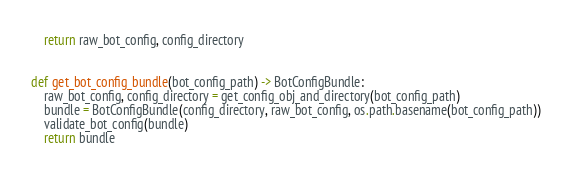<code> <loc_0><loc_0><loc_500><loc_500><_Python_>    return raw_bot_config, config_directory


def get_bot_config_bundle(bot_config_path) -> BotConfigBundle:
    raw_bot_config, config_directory = get_config_obj_and_directory(bot_config_path)
    bundle = BotConfigBundle(config_directory, raw_bot_config, os.path.basename(bot_config_path))
    validate_bot_config(bundle)
    return bundle

</code> 